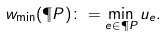<formula> <loc_0><loc_0><loc_500><loc_500>w _ { \tt \min } ( \P P ) \colon = \min _ { e \in \P P } u _ { e } .</formula> 